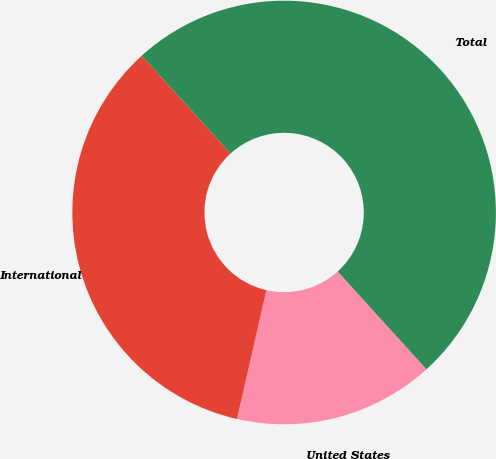<chart> <loc_0><loc_0><loc_500><loc_500><pie_chart><fcel>United States<fcel>International<fcel>Total<nl><fcel>15.3%<fcel>34.7%<fcel>50.0%<nl></chart> 